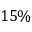Convert formula to latex. <formula><loc_0><loc_0><loc_500><loc_500>1 5 \%</formula> 